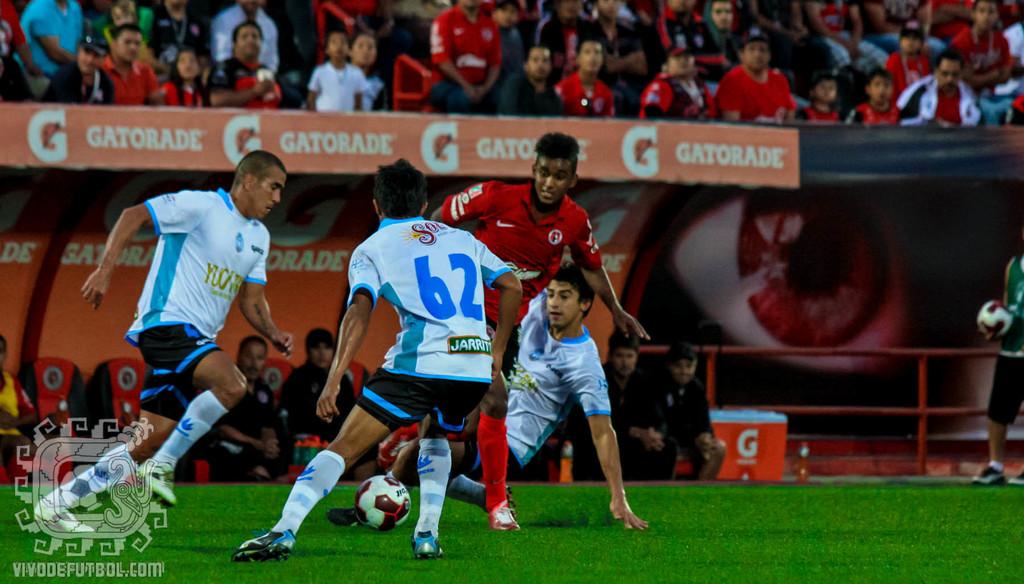What number is the player?
Your answer should be very brief. 62. 